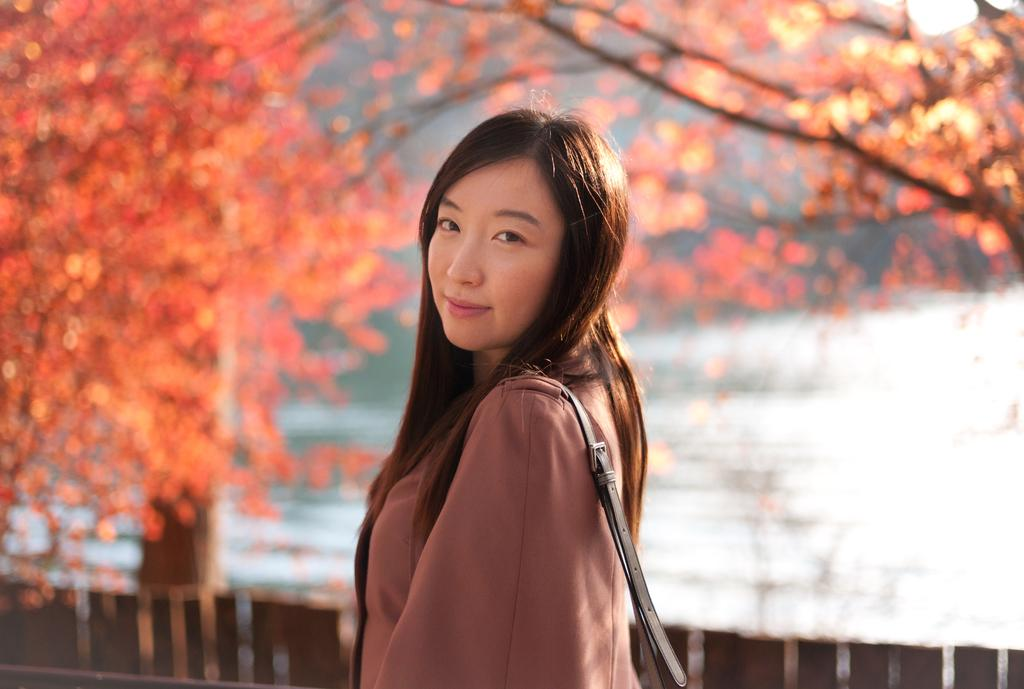Who is present in the image? There is a woman in the image. What is the woman wearing? The woman is wearing a coat. What type of natural element can be seen at the top of the image? There is a tree visible at the top of the image. What type of landscape feature can be seen at the back side of the image? There is water visible at the back side of the image. What type of brush is the woman using to clean the ground in the image? There is no brush or cleaning activity visible in the image. 